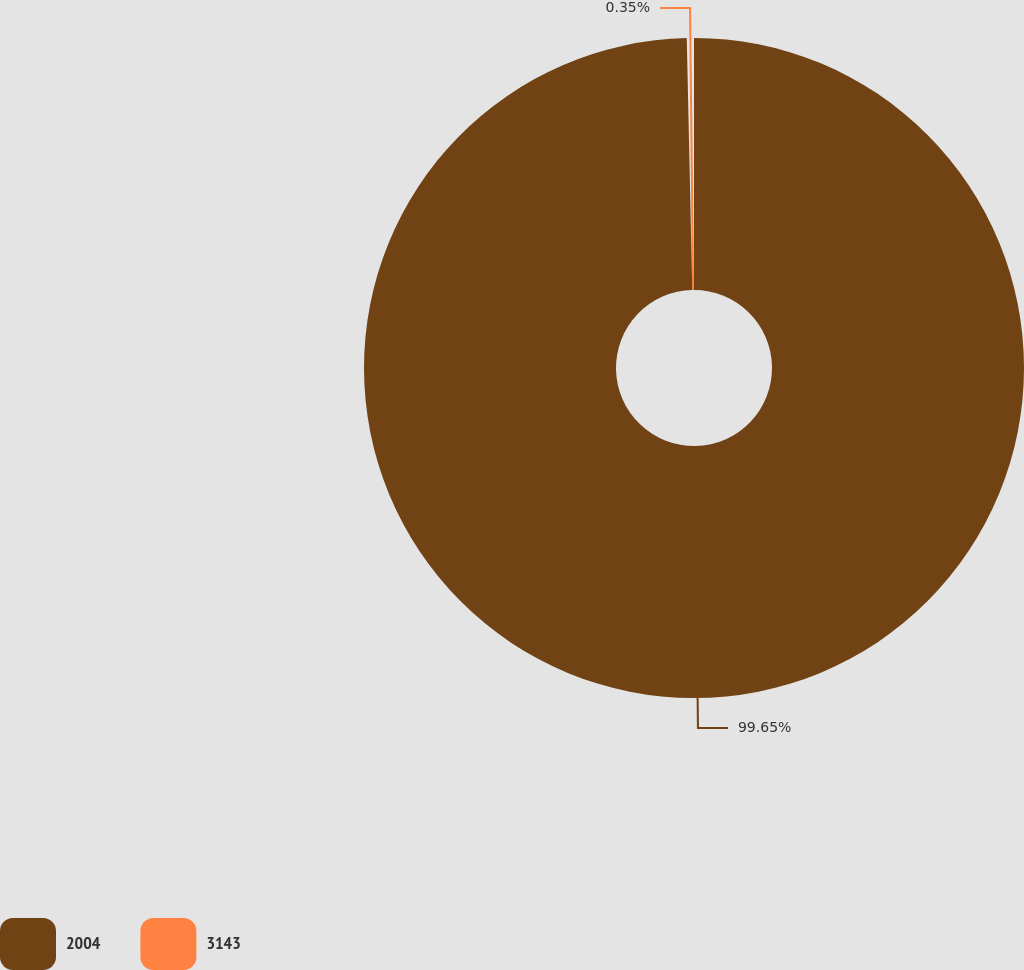Convert chart. <chart><loc_0><loc_0><loc_500><loc_500><pie_chart><fcel>2004<fcel>3143<nl><fcel>99.65%<fcel>0.35%<nl></chart> 